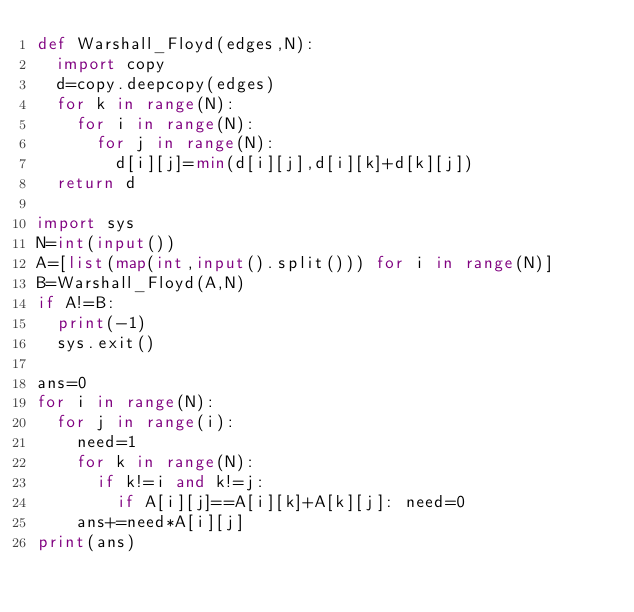<code> <loc_0><loc_0><loc_500><loc_500><_Python_>def Warshall_Floyd(edges,N):
  import copy
  d=copy.deepcopy(edges)
  for k in range(N):
    for i in range(N):
      for j in range(N):
        d[i][j]=min(d[i][j],d[i][k]+d[k][j])
  return d

import sys
N=int(input())
A=[list(map(int,input().split())) for i in range(N)]
B=Warshall_Floyd(A,N)
if A!=B:
  print(-1)
  sys.exit()

ans=0
for i in range(N):
  for j in range(i):
    need=1
    for k in range(N):
      if k!=i and k!=j:
        if A[i][j]==A[i][k]+A[k][j]: need=0
    ans+=need*A[i][j]
print(ans)</code> 